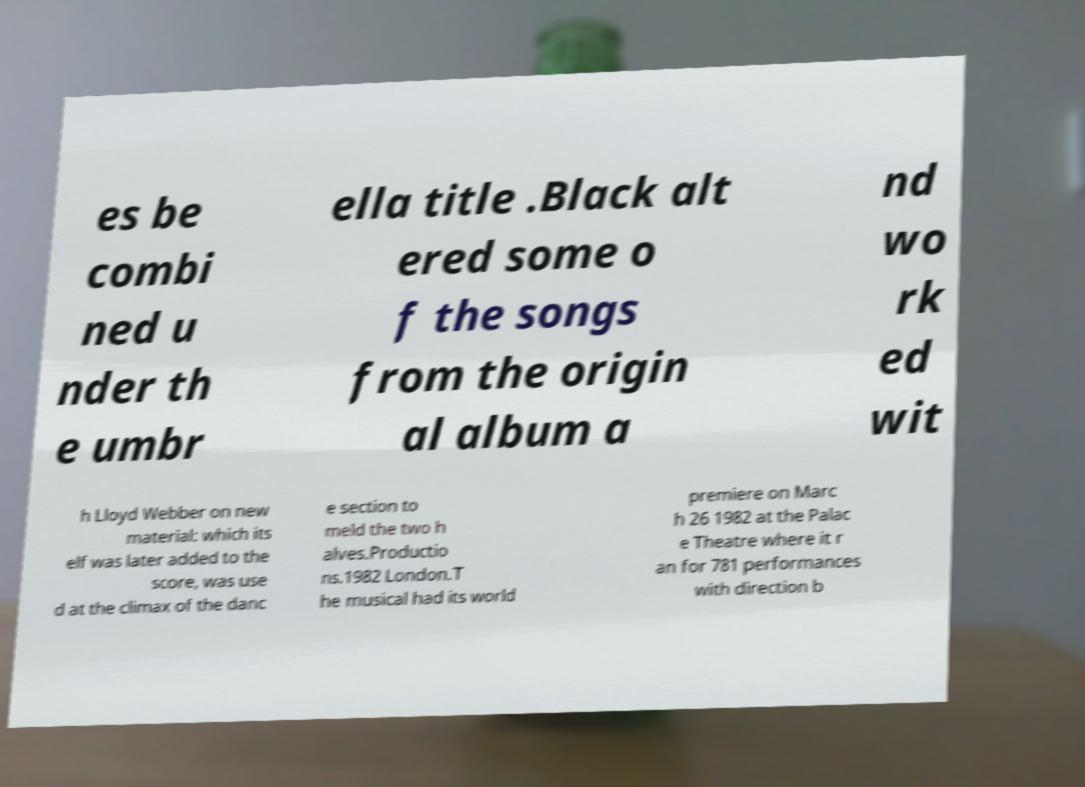Please read and relay the text visible in this image. What does it say? es be combi ned u nder th e umbr ella title .Black alt ered some o f the songs from the origin al album a nd wo rk ed wit h Lloyd Webber on new material: which its elf was later added to the score, was use d at the climax of the danc e section to meld the two h alves.Productio ns.1982 London.T he musical had its world premiere on Marc h 26 1982 at the Palac e Theatre where it r an for 781 performances with direction b 